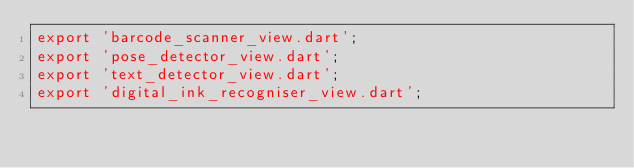Convert code to text. <code><loc_0><loc_0><loc_500><loc_500><_Dart_>export 'barcode_scanner_view.dart';
export 'pose_detector_view.dart';
export 'text_detector_view.dart';
export 'digital_ink_recogniser_view.dart';
</code> 